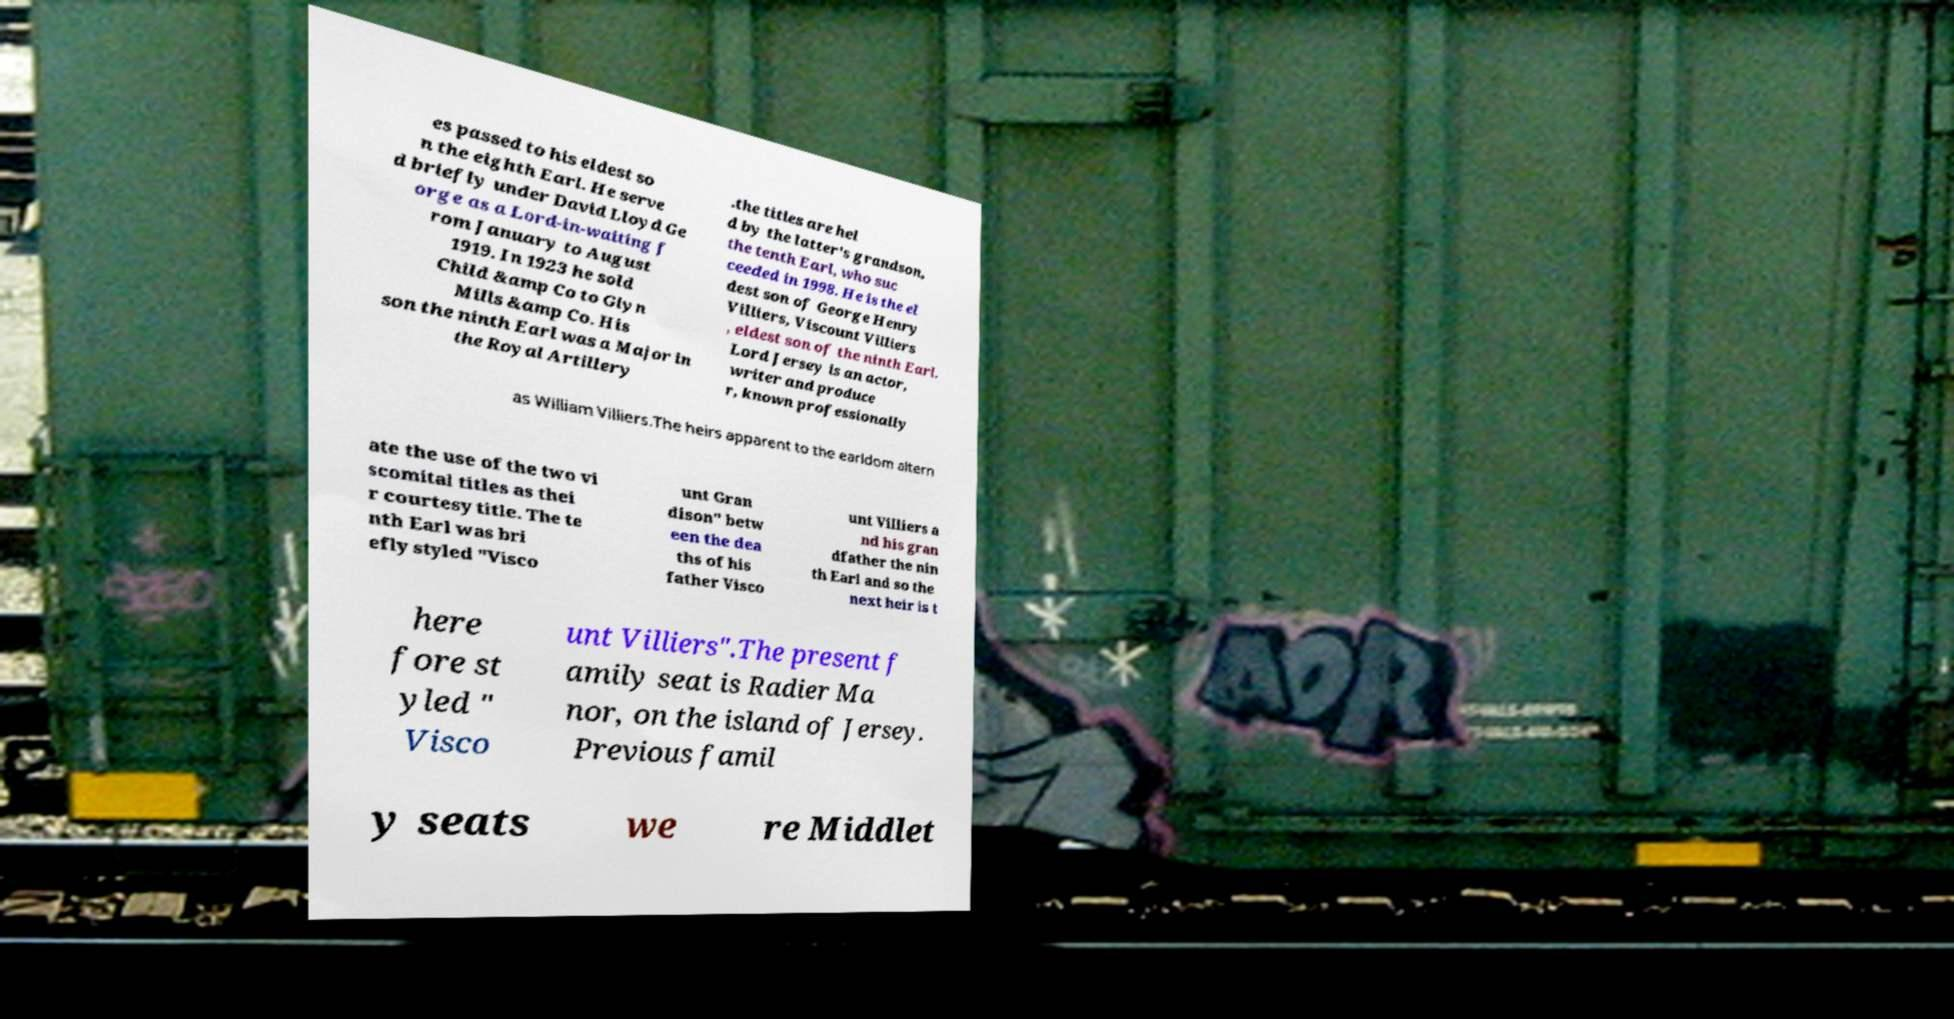I need the written content from this picture converted into text. Can you do that? es passed to his eldest so n the eighth Earl. He serve d briefly under David Lloyd Ge orge as a Lord-in-waiting f rom January to August 1919. In 1923 he sold Child &amp Co to Glyn Mills &amp Co. His son the ninth Earl was a Major in the Royal Artillery .the titles are hel d by the latter's grandson, the tenth Earl, who suc ceeded in 1998. He is the el dest son of George Henry Villiers, Viscount Villiers , eldest son of the ninth Earl. Lord Jersey is an actor, writer and produce r, known professionally as William Villiers.The heirs apparent to the earldom altern ate the use of the two vi scomital titles as thei r courtesy title. The te nth Earl was bri efly styled "Visco unt Gran dison" betw een the dea ths of his father Visco unt Villiers a nd his gran dfather the nin th Earl and so the next heir is t here fore st yled " Visco unt Villiers".The present f amily seat is Radier Ma nor, on the island of Jersey. Previous famil y seats we re Middlet 